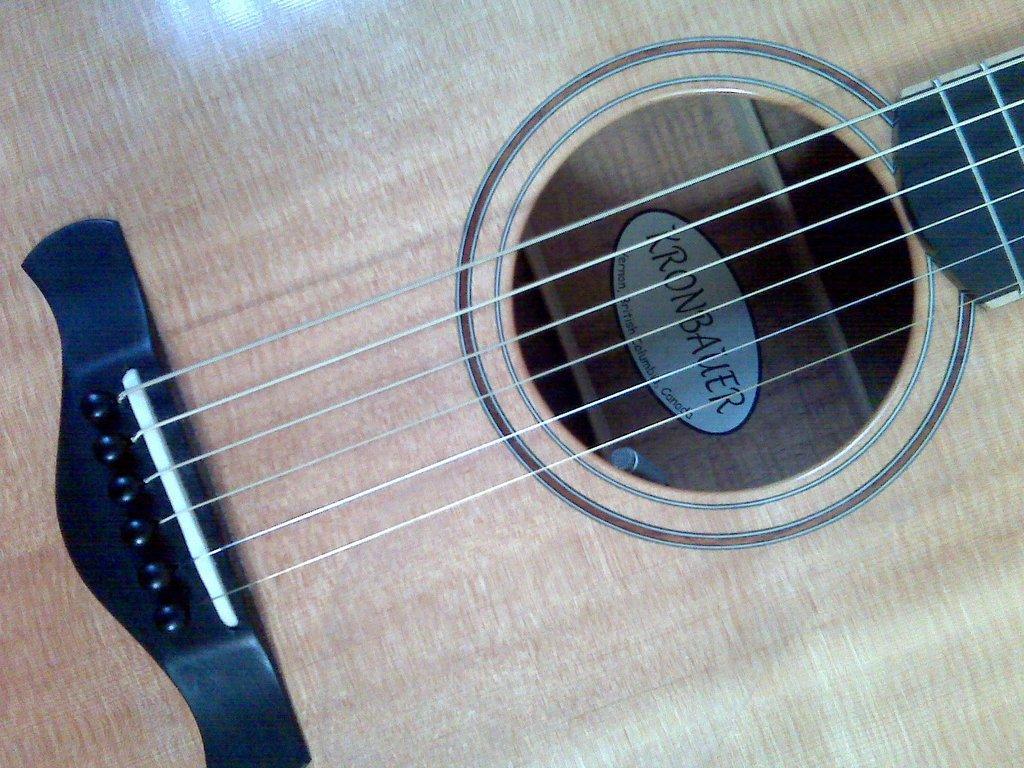Please provide a concise description of this image. In this image we can see the strings of a guitar. 